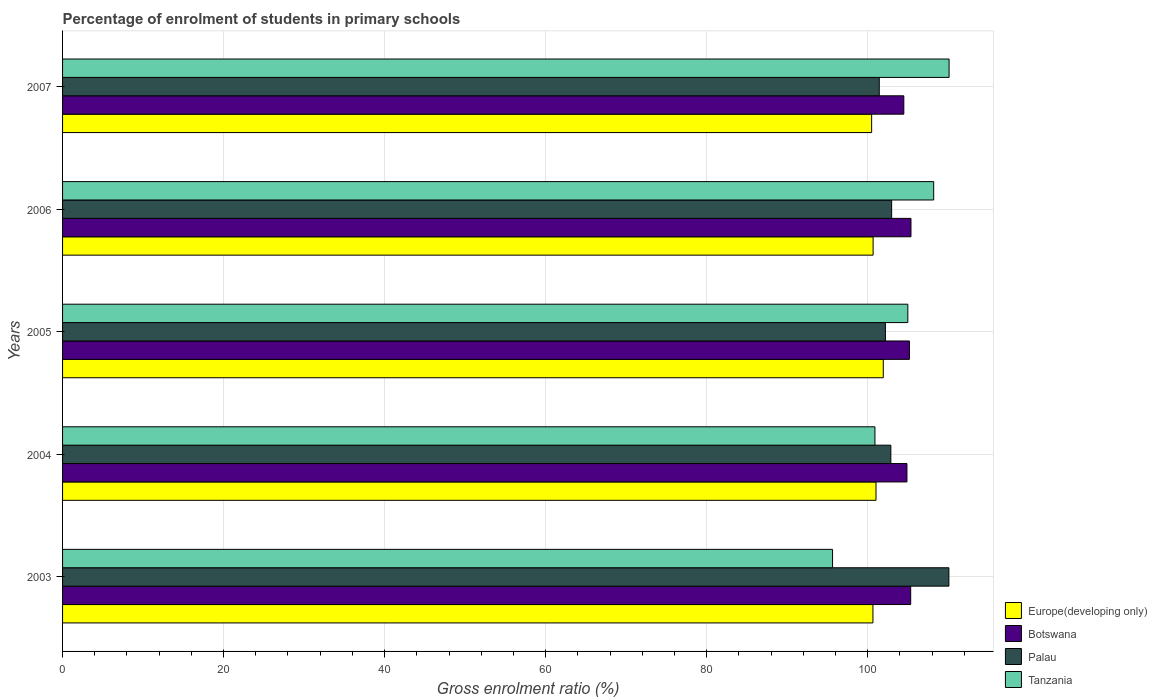How many different coloured bars are there?
Provide a short and direct response. 4. Are the number of bars on each tick of the Y-axis equal?
Your answer should be very brief. Yes. How many bars are there on the 3rd tick from the top?
Make the answer very short. 4. What is the percentage of students enrolled in primary schools in Palau in 2007?
Provide a short and direct response. 101.45. Across all years, what is the maximum percentage of students enrolled in primary schools in Botswana?
Offer a terse response. 105.38. Across all years, what is the minimum percentage of students enrolled in primary schools in Tanzania?
Give a very brief answer. 95.65. In which year was the percentage of students enrolled in primary schools in Palau maximum?
Offer a terse response. 2003. What is the total percentage of students enrolled in primary schools in Europe(developing only) in the graph?
Offer a terse response. 504.82. What is the difference between the percentage of students enrolled in primary schools in Tanzania in 2004 and that in 2005?
Ensure brevity in your answer.  -4.09. What is the difference between the percentage of students enrolled in primary schools in Europe(developing only) in 2004 and the percentage of students enrolled in primary schools in Tanzania in 2005?
Provide a short and direct response. -3.95. What is the average percentage of students enrolled in primary schools in Europe(developing only) per year?
Make the answer very short. 100.96. In the year 2003, what is the difference between the percentage of students enrolled in primary schools in Europe(developing only) and percentage of students enrolled in primary schools in Tanzania?
Offer a terse response. 5.01. In how many years, is the percentage of students enrolled in primary schools in Tanzania greater than 56 %?
Your answer should be very brief. 5. What is the ratio of the percentage of students enrolled in primary schools in Botswana in 2003 to that in 2007?
Your response must be concise. 1.01. Is the percentage of students enrolled in primary schools in Palau in 2005 less than that in 2007?
Your answer should be very brief. No. Is the difference between the percentage of students enrolled in primary schools in Europe(developing only) in 2003 and 2006 greater than the difference between the percentage of students enrolled in primary schools in Tanzania in 2003 and 2006?
Provide a short and direct response. Yes. What is the difference between the highest and the second highest percentage of students enrolled in primary schools in Palau?
Offer a very short reply. 7.11. What is the difference between the highest and the lowest percentage of students enrolled in primary schools in Botswana?
Make the answer very short. 0.89. In how many years, is the percentage of students enrolled in primary schools in Europe(developing only) greater than the average percentage of students enrolled in primary schools in Europe(developing only) taken over all years?
Your answer should be compact. 2. Is the sum of the percentage of students enrolled in primary schools in Botswana in 2004 and 2006 greater than the maximum percentage of students enrolled in primary schools in Palau across all years?
Your answer should be compact. Yes. Is it the case that in every year, the sum of the percentage of students enrolled in primary schools in Palau and percentage of students enrolled in primary schools in Tanzania is greater than the sum of percentage of students enrolled in primary schools in Botswana and percentage of students enrolled in primary schools in Europe(developing only)?
Keep it short and to the point. No. What does the 2nd bar from the top in 2007 represents?
Your response must be concise. Palau. What does the 1st bar from the bottom in 2006 represents?
Your answer should be compact. Europe(developing only). How many years are there in the graph?
Offer a very short reply. 5. How many legend labels are there?
Provide a succinct answer. 4. What is the title of the graph?
Your response must be concise. Percentage of enrolment of students in primary schools. Does "Guam" appear as one of the legend labels in the graph?
Offer a very short reply. No. What is the label or title of the X-axis?
Your response must be concise. Gross enrolment ratio (%). What is the Gross enrolment ratio (%) of Europe(developing only) in 2003?
Provide a succinct answer. 100.66. What is the Gross enrolment ratio (%) of Botswana in 2003?
Offer a very short reply. 105.35. What is the Gross enrolment ratio (%) in Palau in 2003?
Offer a terse response. 110.09. What is the Gross enrolment ratio (%) in Tanzania in 2003?
Keep it short and to the point. 95.65. What is the Gross enrolment ratio (%) of Europe(developing only) in 2004?
Offer a terse response. 101.04. What is the Gross enrolment ratio (%) in Botswana in 2004?
Give a very brief answer. 104.88. What is the Gross enrolment ratio (%) in Palau in 2004?
Keep it short and to the point. 102.88. What is the Gross enrolment ratio (%) of Tanzania in 2004?
Provide a succinct answer. 100.91. What is the Gross enrolment ratio (%) in Europe(developing only) in 2005?
Provide a short and direct response. 101.94. What is the Gross enrolment ratio (%) of Botswana in 2005?
Make the answer very short. 105.19. What is the Gross enrolment ratio (%) of Palau in 2005?
Your answer should be compact. 102.21. What is the Gross enrolment ratio (%) of Tanzania in 2005?
Your answer should be very brief. 104.99. What is the Gross enrolment ratio (%) of Europe(developing only) in 2006?
Provide a succinct answer. 100.68. What is the Gross enrolment ratio (%) in Botswana in 2006?
Make the answer very short. 105.38. What is the Gross enrolment ratio (%) of Palau in 2006?
Your answer should be very brief. 102.98. What is the Gross enrolment ratio (%) of Tanzania in 2006?
Your answer should be compact. 108.21. What is the Gross enrolment ratio (%) in Europe(developing only) in 2007?
Give a very brief answer. 100.5. What is the Gross enrolment ratio (%) in Botswana in 2007?
Make the answer very short. 104.49. What is the Gross enrolment ratio (%) in Palau in 2007?
Provide a succinct answer. 101.45. What is the Gross enrolment ratio (%) of Tanzania in 2007?
Offer a very short reply. 110.12. Across all years, what is the maximum Gross enrolment ratio (%) of Europe(developing only)?
Your answer should be very brief. 101.94. Across all years, what is the maximum Gross enrolment ratio (%) of Botswana?
Provide a short and direct response. 105.38. Across all years, what is the maximum Gross enrolment ratio (%) of Palau?
Offer a terse response. 110.09. Across all years, what is the maximum Gross enrolment ratio (%) in Tanzania?
Give a very brief answer. 110.12. Across all years, what is the minimum Gross enrolment ratio (%) of Europe(developing only)?
Offer a very short reply. 100.5. Across all years, what is the minimum Gross enrolment ratio (%) in Botswana?
Your answer should be very brief. 104.49. Across all years, what is the minimum Gross enrolment ratio (%) of Palau?
Give a very brief answer. 101.45. Across all years, what is the minimum Gross enrolment ratio (%) of Tanzania?
Keep it short and to the point. 95.65. What is the total Gross enrolment ratio (%) of Europe(developing only) in the graph?
Offer a terse response. 504.82. What is the total Gross enrolment ratio (%) in Botswana in the graph?
Give a very brief answer. 525.3. What is the total Gross enrolment ratio (%) of Palau in the graph?
Your answer should be compact. 519.62. What is the total Gross enrolment ratio (%) in Tanzania in the graph?
Offer a terse response. 519.87. What is the difference between the Gross enrolment ratio (%) in Europe(developing only) in 2003 and that in 2004?
Make the answer very short. -0.38. What is the difference between the Gross enrolment ratio (%) of Botswana in 2003 and that in 2004?
Keep it short and to the point. 0.47. What is the difference between the Gross enrolment ratio (%) in Palau in 2003 and that in 2004?
Keep it short and to the point. 7.21. What is the difference between the Gross enrolment ratio (%) of Tanzania in 2003 and that in 2004?
Give a very brief answer. -5.26. What is the difference between the Gross enrolment ratio (%) of Europe(developing only) in 2003 and that in 2005?
Offer a very short reply. -1.28. What is the difference between the Gross enrolment ratio (%) of Botswana in 2003 and that in 2005?
Provide a short and direct response. 0.16. What is the difference between the Gross enrolment ratio (%) of Palau in 2003 and that in 2005?
Give a very brief answer. 7.89. What is the difference between the Gross enrolment ratio (%) of Tanzania in 2003 and that in 2005?
Ensure brevity in your answer.  -9.35. What is the difference between the Gross enrolment ratio (%) in Europe(developing only) in 2003 and that in 2006?
Provide a short and direct response. -0.02. What is the difference between the Gross enrolment ratio (%) in Botswana in 2003 and that in 2006?
Make the answer very short. -0.04. What is the difference between the Gross enrolment ratio (%) of Palau in 2003 and that in 2006?
Offer a terse response. 7.11. What is the difference between the Gross enrolment ratio (%) of Tanzania in 2003 and that in 2006?
Provide a short and direct response. -12.56. What is the difference between the Gross enrolment ratio (%) in Europe(developing only) in 2003 and that in 2007?
Make the answer very short. 0.16. What is the difference between the Gross enrolment ratio (%) of Botswana in 2003 and that in 2007?
Provide a succinct answer. 0.86. What is the difference between the Gross enrolment ratio (%) of Palau in 2003 and that in 2007?
Provide a short and direct response. 8.65. What is the difference between the Gross enrolment ratio (%) of Tanzania in 2003 and that in 2007?
Your answer should be compact. -14.47. What is the difference between the Gross enrolment ratio (%) in Europe(developing only) in 2004 and that in 2005?
Your answer should be compact. -0.9. What is the difference between the Gross enrolment ratio (%) of Botswana in 2004 and that in 2005?
Make the answer very short. -0.31. What is the difference between the Gross enrolment ratio (%) in Palau in 2004 and that in 2005?
Your answer should be compact. 0.68. What is the difference between the Gross enrolment ratio (%) of Tanzania in 2004 and that in 2005?
Make the answer very short. -4.09. What is the difference between the Gross enrolment ratio (%) of Europe(developing only) in 2004 and that in 2006?
Offer a very short reply. 0.36. What is the difference between the Gross enrolment ratio (%) of Botswana in 2004 and that in 2006?
Keep it short and to the point. -0.5. What is the difference between the Gross enrolment ratio (%) in Palau in 2004 and that in 2006?
Offer a terse response. -0.1. What is the difference between the Gross enrolment ratio (%) in Tanzania in 2004 and that in 2006?
Give a very brief answer. -7.3. What is the difference between the Gross enrolment ratio (%) of Europe(developing only) in 2004 and that in 2007?
Offer a terse response. 0.54. What is the difference between the Gross enrolment ratio (%) in Botswana in 2004 and that in 2007?
Provide a short and direct response. 0.39. What is the difference between the Gross enrolment ratio (%) in Palau in 2004 and that in 2007?
Your response must be concise. 1.44. What is the difference between the Gross enrolment ratio (%) in Tanzania in 2004 and that in 2007?
Provide a succinct answer. -9.21. What is the difference between the Gross enrolment ratio (%) in Europe(developing only) in 2005 and that in 2006?
Provide a succinct answer. 1.26. What is the difference between the Gross enrolment ratio (%) of Botswana in 2005 and that in 2006?
Your answer should be very brief. -0.19. What is the difference between the Gross enrolment ratio (%) of Palau in 2005 and that in 2006?
Offer a very short reply. -0.77. What is the difference between the Gross enrolment ratio (%) of Tanzania in 2005 and that in 2006?
Offer a very short reply. -3.21. What is the difference between the Gross enrolment ratio (%) of Europe(developing only) in 2005 and that in 2007?
Give a very brief answer. 1.44. What is the difference between the Gross enrolment ratio (%) in Botswana in 2005 and that in 2007?
Make the answer very short. 0.7. What is the difference between the Gross enrolment ratio (%) in Palau in 2005 and that in 2007?
Make the answer very short. 0.76. What is the difference between the Gross enrolment ratio (%) of Tanzania in 2005 and that in 2007?
Keep it short and to the point. -5.13. What is the difference between the Gross enrolment ratio (%) of Europe(developing only) in 2006 and that in 2007?
Offer a very short reply. 0.18. What is the difference between the Gross enrolment ratio (%) in Botswana in 2006 and that in 2007?
Offer a terse response. 0.89. What is the difference between the Gross enrolment ratio (%) of Palau in 2006 and that in 2007?
Make the answer very short. 1.54. What is the difference between the Gross enrolment ratio (%) of Tanzania in 2006 and that in 2007?
Provide a succinct answer. -1.91. What is the difference between the Gross enrolment ratio (%) in Europe(developing only) in 2003 and the Gross enrolment ratio (%) in Botswana in 2004?
Your response must be concise. -4.22. What is the difference between the Gross enrolment ratio (%) of Europe(developing only) in 2003 and the Gross enrolment ratio (%) of Palau in 2004?
Offer a terse response. -2.23. What is the difference between the Gross enrolment ratio (%) in Europe(developing only) in 2003 and the Gross enrolment ratio (%) in Tanzania in 2004?
Give a very brief answer. -0.25. What is the difference between the Gross enrolment ratio (%) in Botswana in 2003 and the Gross enrolment ratio (%) in Palau in 2004?
Your response must be concise. 2.47. What is the difference between the Gross enrolment ratio (%) of Botswana in 2003 and the Gross enrolment ratio (%) of Tanzania in 2004?
Your response must be concise. 4.44. What is the difference between the Gross enrolment ratio (%) of Palau in 2003 and the Gross enrolment ratio (%) of Tanzania in 2004?
Ensure brevity in your answer.  9.19. What is the difference between the Gross enrolment ratio (%) of Europe(developing only) in 2003 and the Gross enrolment ratio (%) of Botswana in 2005?
Offer a terse response. -4.53. What is the difference between the Gross enrolment ratio (%) of Europe(developing only) in 2003 and the Gross enrolment ratio (%) of Palau in 2005?
Provide a succinct answer. -1.55. What is the difference between the Gross enrolment ratio (%) in Europe(developing only) in 2003 and the Gross enrolment ratio (%) in Tanzania in 2005?
Your answer should be compact. -4.33. What is the difference between the Gross enrolment ratio (%) in Botswana in 2003 and the Gross enrolment ratio (%) in Palau in 2005?
Make the answer very short. 3.14. What is the difference between the Gross enrolment ratio (%) of Botswana in 2003 and the Gross enrolment ratio (%) of Tanzania in 2005?
Ensure brevity in your answer.  0.36. What is the difference between the Gross enrolment ratio (%) of Palau in 2003 and the Gross enrolment ratio (%) of Tanzania in 2005?
Your answer should be very brief. 5.1. What is the difference between the Gross enrolment ratio (%) of Europe(developing only) in 2003 and the Gross enrolment ratio (%) of Botswana in 2006?
Your answer should be very brief. -4.73. What is the difference between the Gross enrolment ratio (%) of Europe(developing only) in 2003 and the Gross enrolment ratio (%) of Palau in 2006?
Offer a very short reply. -2.32. What is the difference between the Gross enrolment ratio (%) of Europe(developing only) in 2003 and the Gross enrolment ratio (%) of Tanzania in 2006?
Your response must be concise. -7.55. What is the difference between the Gross enrolment ratio (%) of Botswana in 2003 and the Gross enrolment ratio (%) of Palau in 2006?
Provide a short and direct response. 2.37. What is the difference between the Gross enrolment ratio (%) of Botswana in 2003 and the Gross enrolment ratio (%) of Tanzania in 2006?
Provide a short and direct response. -2.86. What is the difference between the Gross enrolment ratio (%) in Palau in 2003 and the Gross enrolment ratio (%) in Tanzania in 2006?
Make the answer very short. 1.89. What is the difference between the Gross enrolment ratio (%) of Europe(developing only) in 2003 and the Gross enrolment ratio (%) of Botswana in 2007?
Keep it short and to the point. -3.84. What is the difference between the Gross enrolment ratio (%) of Europe(developing only) in 2003 and the Gross enrolment ratio (%) of Palau in 2007?
Your answer should be compact. -0.79. What is the difference between the Gross enrolment ratio (%) of Europe(developing only) in 2003 and the Gross enrolment ratio (%) of Tanzania in 2007?
Your answer should be very brief. -9.46. What is the difference between the Gross enrolment ratio (%) of Botswana in 2003 and the Gross enrolment ratio (%) of Palau in 2007?
Ensure brevity in your answer.  3.9. What is the difference between the Gross enrolment ratio (%) in Botswana in 2003 and the Gross enrolment ratio (%) in Tanzania in 2007?
Offer a terse response. -4.77. What is the difference between the Gross enrolment ratio (%) of Palau in 2003 and the Gross enrolment ratio (%) of Tanzania in 2007?
Offer a terse response. -0.02. What is the difference between the Gross enrolment ratio (%) in Europe(developing only) in 2004 and the Gross enrolment ratio (%) in Botswana in 2005?
Keep it short and to the point. -4.15. What is the difference between the Gross enrolment ratio (%) in Europe(developing only) in 2004 and the Gross enrolment ratio (%) in Palau in 2005?
Ensure brevity in your answer.  -1.17. What is the difference between the Gross enrolment ratio (%) in Europe(developing only) in 2004 and the Gross enrolment ratio (%) in Tanzania in 2005?
Give a very brief answer. -3.95. What is the difference between the Gross enrolment ratio (%) in Botswana in 2004 and the Gross enrolment ratio (%) in Palau in 2005?
Ensure brevity in your answer.  2.67. What is the difference between the Gross enrolment ratio (%) in Botswana in 2004 and the Gross enrolment ratio (%) in Tanzania in 2005?
Provide a short and direct response. -0.11. What is the difference between the Gross enrolment ratio (%) of Palau in 2004 and the Gross enrolment ratio (%) of Tanzania in 2005?
Your answer should be very brief. -2.11. What is the difference between the Gross enrolment ratio (%) in Europe(developing only) in 2004 and the Gross enrolment ratio (%) in Botswana in 2006?
Keep it short and to the point. -4.34. What is the difference between the Gross enrolment ratio (%) of Europe(developing only) in 2004 and the Gross enrolment ratio (%) of Palau in 2006?
Your answer should be very brief. -1.94. What is the difference between the Gross enrolment ratio (%) in Europe(developing only) in 2004 and the Gross enrolment ratio (%) in Tanzania in 2006?
Your answer should be very brief. -7.17. What is the difference between the Gross enrolment ratio (%) in Botswana in 2004 and the Gross enrolment ratio (%) in Palau in 2006?
Your answer should be compact. 1.9. What is the difference between the Gross enrolment ratio (%) of Botswana in 2004 and the Gross enrolment ratio (%) of Tanzania in 2006?
Keep it short and to the point. -3.32. What is the difference between the Gross enrolment ratio (%) in Palau in 2004 and the Gross enrolment ratio (%) in Tanzania in 2006?
Provide a short and direct response. -5.32. What is the difference between the Gross enrolment ratio (%) in Europe(developing only) in 2004 and the Gross enrolment ratio (%) in Botswana in 2007?
Provide a short and direct response. -3.45. What is the difference between the Gross enrolment ratio (%) of Europe(developing only) in 2004 and the Gross enrolment ratio (%) of Palau in 2007?
Give a very brief answer. -0.41. What is the difference between the Gross enrolment ratio (%) in Europe(developing only) in 2004 and the Gross enrolment ratio (%) in Tanzania in 2007?
Your response must be concise. -9.08. What is the difference between the Gross enrolment ratio (%) in Botswana in 2004 and the Gross enrolment ratio (%) in Palau in 2007?
Your answer should be very brief. 3.44. What is the difference between the Gross enrolment ratio (%) of Botswana in 2004 and the Gross enrolment ratio (%) of Tanzania in 2007?
Ensure brevity in your answer.  -5.24. What is the difference between the Gross enrolment ratio (%) of Palau in 2004 and the Gross enrolment ratio (%) of Tanzania in 2007?
Provide a succinct answer. -7.23. What is the difference between the Gross enrolment ratio (%) in Europe(developing only) in 2005 and the Gross enrolment ratio (%) in Botswana in 2006?
Offer a very short reply. -3.44. What is the difference between the Gross enrolment ratio (%) of Europe(developing only) in 2005 and the Gross enrolment ratio (%) of Palau in 2006?
Offer a terse response. -1.04. What is the difference between the Gross enrolment ratio (%) in Europe(developing only) in 2005 and the Gross enrolment ratio (%) in Tanzania in 2006?
Keep it short and to the point. -6.26. What is the difference between the Gross enrolment ratio (%) of Botswana in 2005 and the Gross enrolment ratio (%) of Palau in 2006?
Offer a terse response. 2.21. What is the difference between the Gross enrolment ratio (%) of Botswana in 2005 and the Gross enrolment ratio (%) of Tanzania in 2006?
Ensure brevity in your answer.  -3.02. What is the difference between the Gross enrolment ratio (%) of Palau in 2005 and the Gross enrolment ratio (%) of Tanzania in 2006?
Make the answer very short. -6. What is the difference between the Gross enrolment ratio (%) of Europe(developing only) in 2005 and the Gross enrolment ratio (%) of Botswana in 2007?
Provide a succinct answer. -2.55. What is the difference between the Gross enrolment ratio (%) of Europe(developing only) in 2005 and the Gross enrolment ratio (%) of Palau in 2007?
Offer a terse response. 0.5. What is the difference between the Gross enrolment ratio (%) of Europe(developing only) in 2005 and the Gross enrolment ratio (%) of Tanzania in 2007?
Provide a succinct answer. -8.18. What is the difference between the Gross enrolment ratio (%) in Botswana in 2005 and the Gross enrolment ratio (%) in Palau in 2007?
Make the answer very short. 3.75. What is the difference between the Gross enrolment ratio (%) in Botswana in 2005 and the Gross enrolment ratio (%) in Tanzania in 2007?
Your answer should be very brief. -4.93. What is the difference between the Gross enrolment ratio (%) in Palau in 2005 and the Gross enrolment ratio (%) in Tanzania in 2007?
Ensure brevity in your answer.  -7.91. What is the difference between the Gross enrolment ratio (%) of Europe(developing only) in 2006 and the Gross enrolment ratio (%) of Botswana in 2007?
Offer a terse response. -3.81. What is the difference between the Gross enrolment ratio (%) in Europe(developing only) in 2006 and the Gross enrolment ratio (%) in Palau in 2007?
Offer a very short reply. -0.76. What is the difference between the Gross enrolment ratio (%) in Europe(developing only) in 2006 and the Gross enrolment ratio (%) in Tanzania in 2007?
Provide a succinct answer. -9.44. What is the difference between the Gross enrolment ratio (%) of Botswana in 2006 and the Gross enrolment ratio (%) of Palau in 2007?
Provide a short and direct response. 3.94. What is the difference between the Gross enrolment ratio (%) of Botswana in 2006 and the Gross enrolment ratio (%) of Tanzania in 2007?
Give a very brief answer. -4.73. What is the difference between the Gross enrolment ratio (%) in Palau in 2006 and the Gross enrolment ratio (%) in Tanzania in 2007?
Ensure brevity in your answer.  -7.14. What is the average Gross enrolment ratio (%) in Europe(developing only) per year?
Offer a terse response. 100.96. What is the average Gross enrolment ratio (%) in Botswana per year?
Keep it short and to the point. 105.06. What is the average Gross enrolment ratio (%) in Palau per year?
Offer a terse response. 103.92. What is the average Gross enrolment ratio (%) in Tanzania per year?
Give a very brief answer. 103.97. In the year 2003, what is the difference between the Gross enrolment ratio (%) of Europe(developing only) and Gross enrolment ratio (%) of Botswana?
Your response must be concise. -4.69. In the year 2003, what is the difference between the Gross enrolment ratio (%) in Europe(developing only) and Gross enrolment ratio (%) in Palau?
Your response must be concise. -9.44. In the year 2003, what is the difference between the Gross enrolment ratio (%) in Europe(developing only) and Gross enrolment ratio (%) in Tanzania?
Offer a very short reply. 5.01. In the year 2003, what is the difference between the Gross enrolment ratio (%) in Botswana and Gross enrolment ratio (%) in Palau?
Your response must be concise. -4.75. In the year 2003, what is the difference between the Gross enrolment ratio (%) of Botswana and Gross enrolment ratio (%) of Tanzania?
Offer a terse response. 9.7. In the year 2003, what is the difference between the Gross enrolment ratio (%) in Palau and Gross enrolment ratio (%) in Tanzania?
Make the answer very short. 14.45. In the year 2004, what is the difference between the Gross enrolment ratio (%) of Europe(developing only) and Gross enrolment ratio (%) of Botswana?
Your answer should be very brief. -3.84. In the year 2004, what is the difference between the Gross enrolment ratio (%) of Europe(developing only) and Gross enrolment ratio (%) of Palau?
Your response must be concise. -1.84. In the year 2004, what is the difference between the Gross enrolment ratio (%) of Europe(developing only) and Gross enrolment ratio (%) of Tanzania?
Provide a short and direct response. 0.13. In the year 2004, what is the difference between the Gross enrolment ratio (%) in Botswana and Gross enrolment ratio (%) in Palau?
Keep it short and to the point. 2. In the year 2004, what is the difference between the Gross enrolment ratio (%) of Botswana and Gross enrolment ratio (%) of Tanzania?
Provide a succinct answer. 3.98. In the year 2004, what is the difference between the Gross enrolment ratio (%) of Palau and Gross enrolment ratio (%) of Tanzania?
Offer a terse response. 1.98. In the year 2005, what is the difference between the Gross enrolment ratio (%) of Europe(developing only) and Gross enrolment ratio (%) of Botswana?
Offer a terse response. -3.25. In the year 2005, what is the difference between the Gross enrolment ratio (%) of Europe(developing only) and Gross enrolment ratio (%) of Palau?
Keep it short and to the point. -0.27. In the year 2005, what is the difference between the Gross enrolment ratio (%) in Europe(developing only) and Gross enrolment ratio (%) in Tanzania?
Provide a short and direct response. -3.05. In the year 2005, what is the difference between the Gross enrolment ratio (%) in Botswana and Gross enrolment ratio (%) in Palau?
Make the answer very short. 2.98. In the year 2005, what is the difference between the Gross enrolment ratio (%) of Botswana and Gross enrolment ratio (%) of Tanzania?
Make the answer very short. 0.2. In the year 2005, what is the difference between the Gross enrolment ratio (%) of Palau and Gross enrolment ratio (%) of Tanzania?
Keep it short and to the point. -2.78. In the year 2006, what is the difference between the Gross enrolment ratio (%) of Europe(developing only) and Gross enrolment ratio (%) of Botswana?
Make the answer very short. -4.7. In the year 2006, what is the difference between the Gross enrolment ratio (%) in Europe(developing only) and Gross enrolment ratio (%) in Palau?
Your answer should be compact. -2.3. In the year 2006, what is the difference between the Gross enrolment ratio (%) in Europe(developing only) and Gross enrolment ratio (%) in Tanzania?
Keep it short and to the point. -7.52. In the year 2006, what is the difference between the Gross enrolment ratio (%) in Botswana and Gross enrolment ratio (%) in Palau?
Your answer should be compact. 2.4. In the year 2006, what is the difference between the Gross enrolment ratio (%) of Botswana and Gross enrolment ratio (%) of Tanzania?
Provide a short and direct response. -2.82. In the year 2006, what is the difference between the Gross enrolment ratio (%) in Palau and Gross enrolment ratio (%) in Tanzania?
Your response must be concise. -5.22. In the year 2007, what is the difference between the Gross enrolment ratio (%) of Europe(developing only) and Gross enrolment ratio (%) of Botswana?
Offer a terse response. -4. In the year 2007, what is the difference between the Gross enrolment ratio (%) in Europe(developing only) and Gross enrolment ratio (%) in Palau?
Give a very brief answer. -0.95. In the year 2007, what is the difference between the Gross enrolment ratio (%) in Europe(developing only) and Gross enrolment ratio (%) in Tanzania?
Ensure brevity in your answer.  -9.62. In the year 2007, what is the difference between the Gross enrolment ratio (%) in Botswana and Gross enrolment ratio (%) in Palau?
Your response must be concise. 3.05. In the year 2007, what is the difference between the Gross enrolment ratio (%) of Botswana and Gross enrolment ratio (%) of Tanzania?
Your answer should be compact. -5.62. In the year 2007, what is the difference between the Gross enrolment ratio (%) of Palau and Gross enrolment ratio (%) of Tanzania?
Your answer should be very brief. -8.67. What is the ratio of the Gross enrolment ratio (%) of Europe(developing only) in 2003 to that in 2004?
Offer a terse response. 1. What is the ratio of the Gross enrolment ratio (%) in Palau in 2003 to that in 2004?
Your answer should be very brief. 1.07. What is the ratio of the Gross enrolment ratio (%) in Tanzania in 2003 to that in 2004?
Keep it short and to the point. 0.95. What is the ratio of the Gross enrolment ratio (%) of Europe(developing only) in 2003 to that in 2005?
Your answer should be compact. 0.99. What is the ratio of the Gross enrolment ratio (%) in Palau in 2003 to that in 2005?
Keep it short and to the point. 1.08. What is the ratio of the Gross enrolment ratio (%) in Tanzania in 2003 to that in 2005?
Offer a very short reply. 0.91. What is the ratio of the Gross enrolment ratio (%) of Palau in 2003 to that in 2006?
Keep it short and to the point. 1.07. What is the ratio of the Gross enrolment ratio (%) of Tanzania in 2003 to that in 2006?
Your answer should be compact. 0.88. What is the ratio of the Gross enrolment ratio (%) of Botswana in 2003 to that in 2007?
Keep it short and to the point. 1.01. What is the ratio of the Gross enrolment ratio (%) of Palau in 2003 to that in 2007?
Ensure brevity in your answer.  1.09. What is the ratio of the Gross enrolment ratio (%) in Tanzania in 2003 to that in 2007?
Offer a terse response. 0.87. What is the ratio of the Gross enrolment ratio (%) of Europe(developing only) in 2004 to that in 2005?
Give a very brief answer. 0.99. What is the ratio of the Gross enrolment ratio (%) in Botswana in 2004 to that in 2005?
Your response must be concise. 1. What is the ratio of the Gross enrolment ratio (%) of Palau in 2004 to that in 2005?
Offer a very short reply. 1.01. What is the ratio of the Gross enrolment ratio (%) in Tanzania in 2004 to that in 2005?
Ensure brevity in your answer.  0.96. What is the ratio of the Gross enrolment ratio (%) in Botswana in 2004 to that in 2006?
Provide a succinct answer. 1. What is the ratio of the Gross enrolment ratio (%) in Tanzania in 2004 to that in 2006?
Give a very brief answer. 0.93. What is the ratio of the Gross enrolment ratio (%) of Europe(developing only) in 2004 to that in 2007?
Provide a succinct answer. 1.01. What is the ratio of the Gross enrolment ratio (%) in Botswana in 2004 to that in 2007?
Your answer should be compact. 1. What is the ratio of the Gross enrolment ratio (%) of Palau in 2004 to that in 2007?
Your response must be concise. 1.01. What is the ratio of the Gross enrolment ratio (%) in Tanzania in 2004 to that in 2007?
Make the answer very short. 0.92. What is the ratio of the Gross enrolment ratio (%) in Europe(developing only) in 2005 to that in 2006?
Offer a very short reply. 1.01. What is the ratio of the Gross enrolment ratio (%) of Palau in 2005 to that in 2006?
Make the answer very short. 0.99. What is the ratio of the Gross enrolment ratio (%) in Tanzania in 2005 to that in 2006?
Provide a short and direct response. 0.97. What is the ratio of the Gross enrolment ratio (%) of Europe(developing only) in 2005 to that in 2007?
Your response must be concise. 1.01. What is the ratio of the Gross enrolment ratio (%) in Botswana in 2005 to that in 2007?
Your response must be concise. 1.01. What is the ratio of the Gross enrolment ratio (%) in Palau in 2005 to that in 2007?
Your answer should be compact. 1.01. What is the ratio of the Gross enrolment ratio (%) in Tanzania in 2005 to that in 2007?
Offer a terse response. 0.95. What is the ratio of the Gross enrolment ratio (%) in Europe(developing only) in 2006 to that in 2007?
Keep it short and to the point. 1. What is the ratio of the Gross enrolment ratio (%) of Botswana in 2006 to that in 2007?
Provide a succinct answer. 1.01. What is the ratio of the Gross enrolment ratio (%) of Palau in 2006 to that in 2007?
Your answer should be compact. 1.02. What is the ratio of the Gross enrolment ratio (%) of Tanzania in 2006 to that in 2007?
Offer a terse response. 0.98. What is the difference between the highest and the second highest Gross enrolment ratio (%) in Europe(developing only)?
Ensure brevity in your answer.  0.9. What is the difference between the highest and the second highest Gross enrolment ratio (%) of Botswana?
Provide a succinct answer. 0.04. What is the difference between the highest and the second highest Gross enrolment ratio (%) in Palau?
Give a very brief answer. 7.11. What is the difference between the highest and the second highest Gross enrolment ratio (%) in Tanzania?
Offer a terse response. 1.91. What is the difference between the highest and the lowest Gross enrolment ratio (%) in Europe(developing only)?
Offer a very short reply. 1.44. What is the difference between the highest and the lowest Gross enrolment ratio (%) in Botswana?
Provide a succinct answer. 0.89. What is the difference between the highest and the lowest Gross enrolment ratio (%) in Palau?
Give a very brief answer. 8.65. What is the difference between the highest and the lowest Gross enrolment ratio (%) in Tanzania?
Offer a terse response. 14.47. 